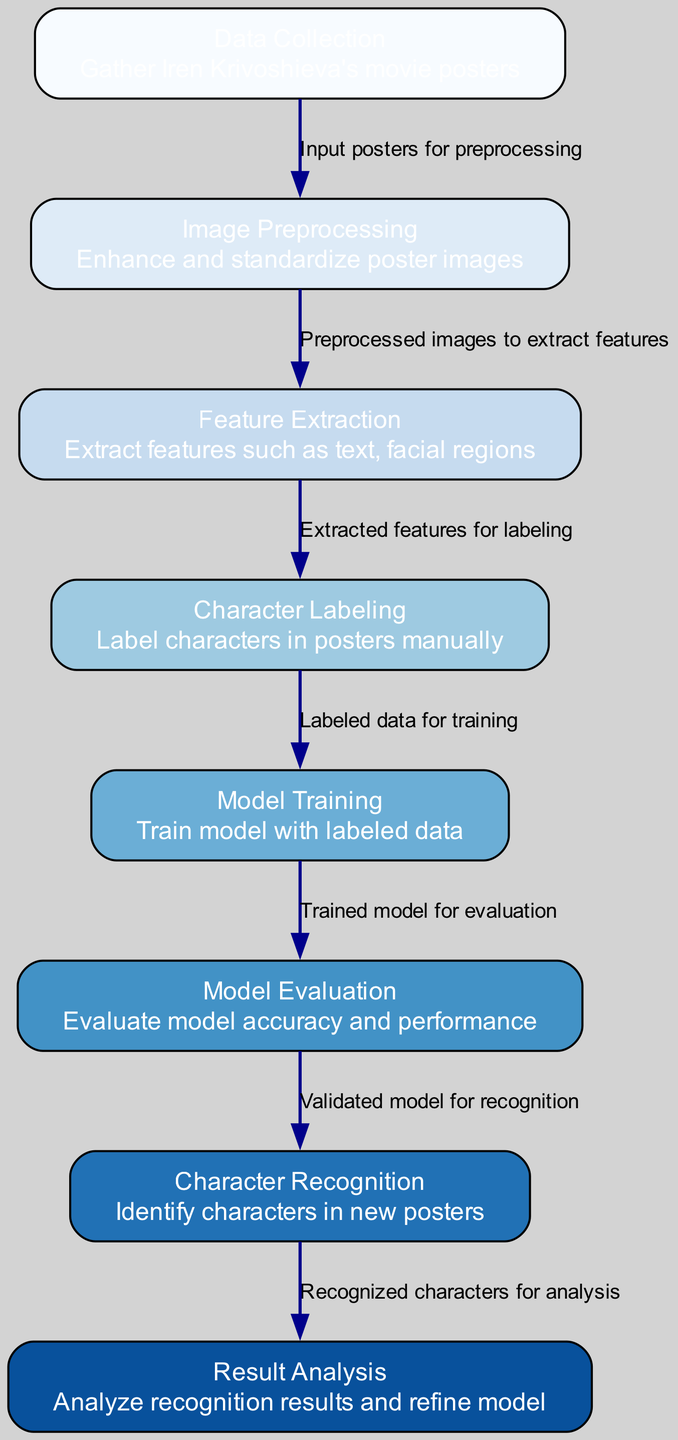What is the first step in the diagram? The first step is labeled as "Data Collection," which involves gathering Iren Krivoshieva's movie posters. It is positioned at the top of the diagram as the initial process.
Answer: Data Collection How many nodes are there in the diagram? By counting the individual nodes listed in the elements section of the diagram, there are a total of 8 nodes representing different stages of the character recognition process.
Answer: 8 What does the edge from "Model Training" to "Model Evaluation" represent? This edge represents the relationship where the trained model is subjected to evaluation to assess accuracy and performance, illustrating a sequential process in the diagram.
Answer: Evaluated model for recognition Which step follows "Character Labeling"? The step that follows "Character Labeling" is "Model Training." This indicates that after manual labeling is completed, the next logical step is to train the model using this labeled data.
Answer: Model Training What is the purpose of "Result Analysis"? The purpose of "Result Analysis" is to analyze recognition results and refine the model based on these findings, which suggests an iterative process aimed at improving character recognition accuracy.
Answer: Analyze recognition results and refine model Which two nodes are directly connected by an edge labeled "Preprocessed images to extract features"? The nodes that are directly connected by this edge are "Image Preprocessing" and "Feature Extraction." This shows the flow of data from preprocessing to feature extraction in the diagram.
Answer: Image Preprocessing and Feature Extraction What step comes before "Character Recognition"? The step that comes before "Character Recognition" is "Model Evaluation." This indicates that the model needs to be evaluated for its performance before it can be applied to recognize characters in new posters.
Answer: Model Evaluation How does "Feature Extraction" relate to "Character Labeling"? The relationship between "Feature Extraction" and "Character Labeling" is that extracted features from the images are used as input when manually labeling the characters in the posters. This indicates a direct dependency where one step informs the next.
Answer: Extracted features for labeling What is the last step in the diagram? The last step in the diagram is "Result Analysis," which is the final process where the recognition results are analyzed. It signifies the culmination of the machine learning process shown in the diagram.
Answer: Result Analysis 